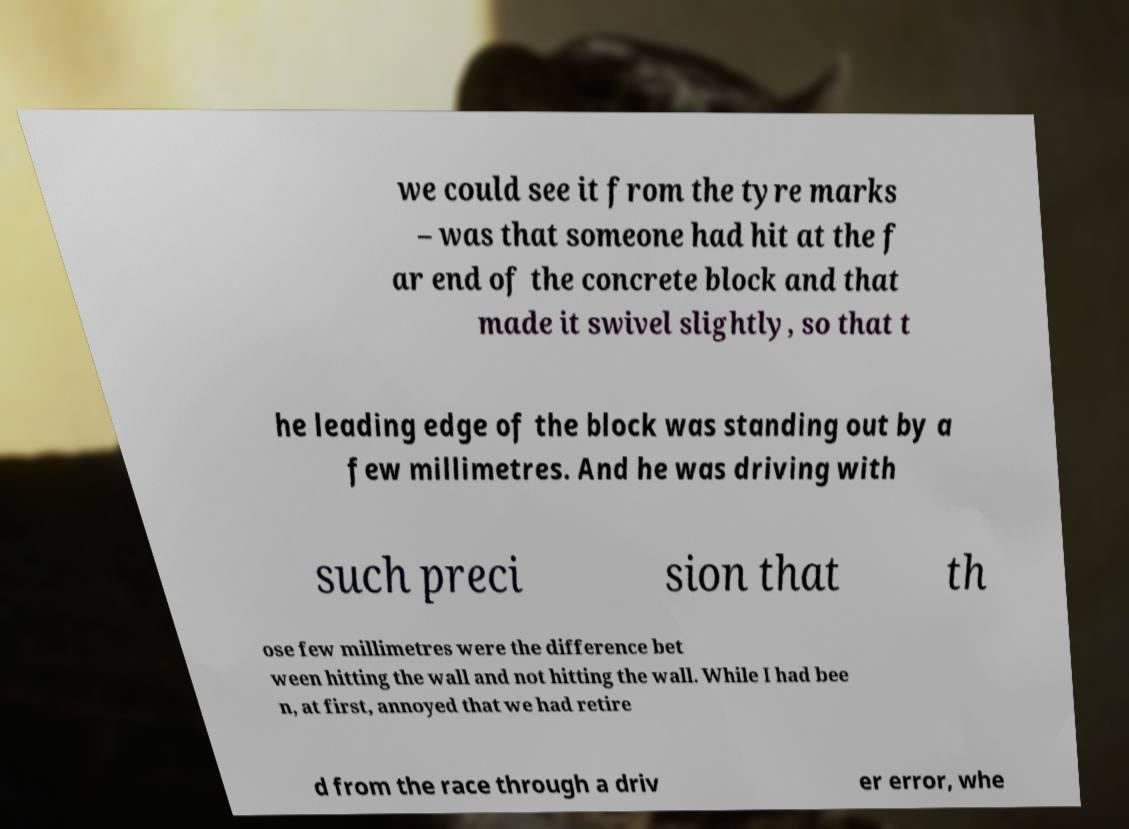I need the written content from this picture converted into text. Can you do that? we could see it from the tyre marks – was that someone had hit at the f ar end of the concrete block and that made it swivel slightly, so that t he leading edge of the block was standing out by a few millimetres. And he was driving with such preci sion that th ose few millimetres were the difference bet ween hitting the wall and not hitting the wall. While I had bee n, at first, annoyed that we had retire d from the race through a driv er error, whe 